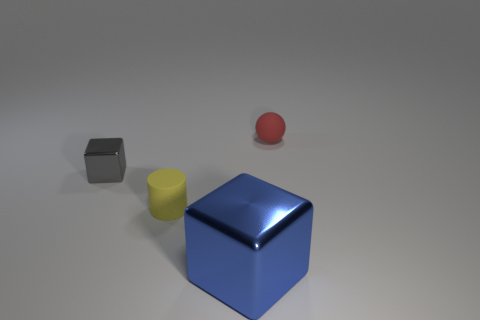What number of blue objects are either small matte spheres or rubber objects?
Keep it short and to the point. 0. Is there a small matte object of the same color as the tiny shiny cube?
Your answer should be very brief. No. What size is the red object that is the same material as the tiny yellow object?
Keep it short and to the point. Small. What number of cubes are small purple shiny objects or small yellow objects?
Offer a terse response. 0. Is the number of tiny green matte objects greater than the number of tiny things?
Make the answer very short. No. How many red matte things have the same size as the ball?
Offer a very short reply. 0. How many objects are tiny matte things left of the ball or tiny red metallic cylinders?
Your response must be concise. 1. Is the number of big green shiny objects less than the number of blue cubes?
Keep it short and to the point. Yes. There is a small red thing that is made of the same material as the yellow thing; what is its shape?
Make the answer very short. Sphere. There is a gray cube; are there any gray things to the right of it?
Make the answer very short. No. 